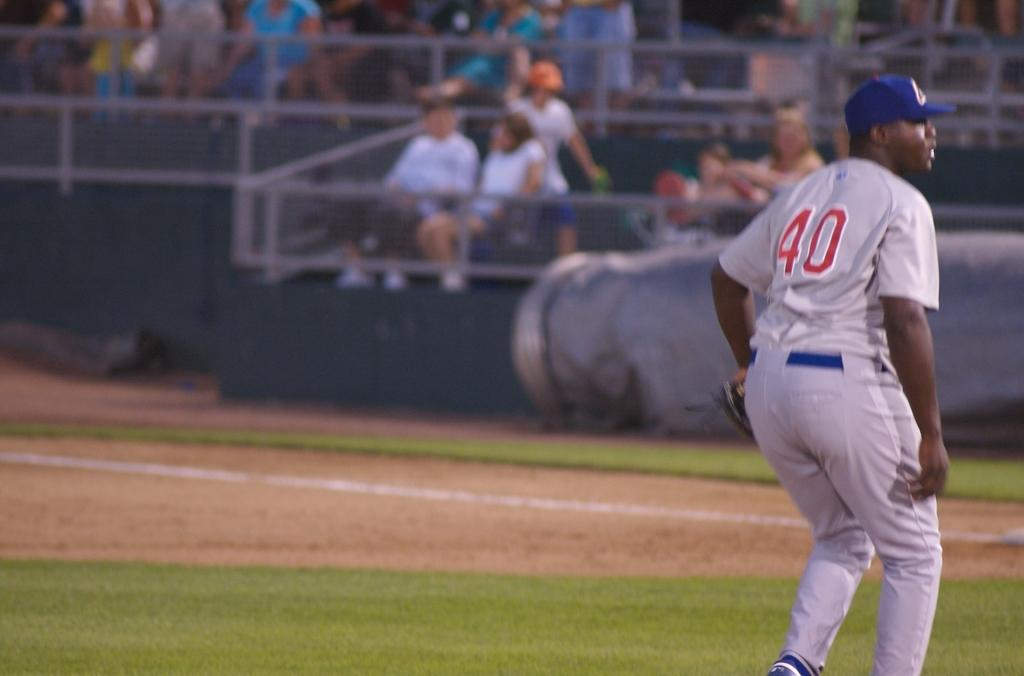<image>
Write a terse but informative summary of the picture. a person wearing the number 40 on their jersey 